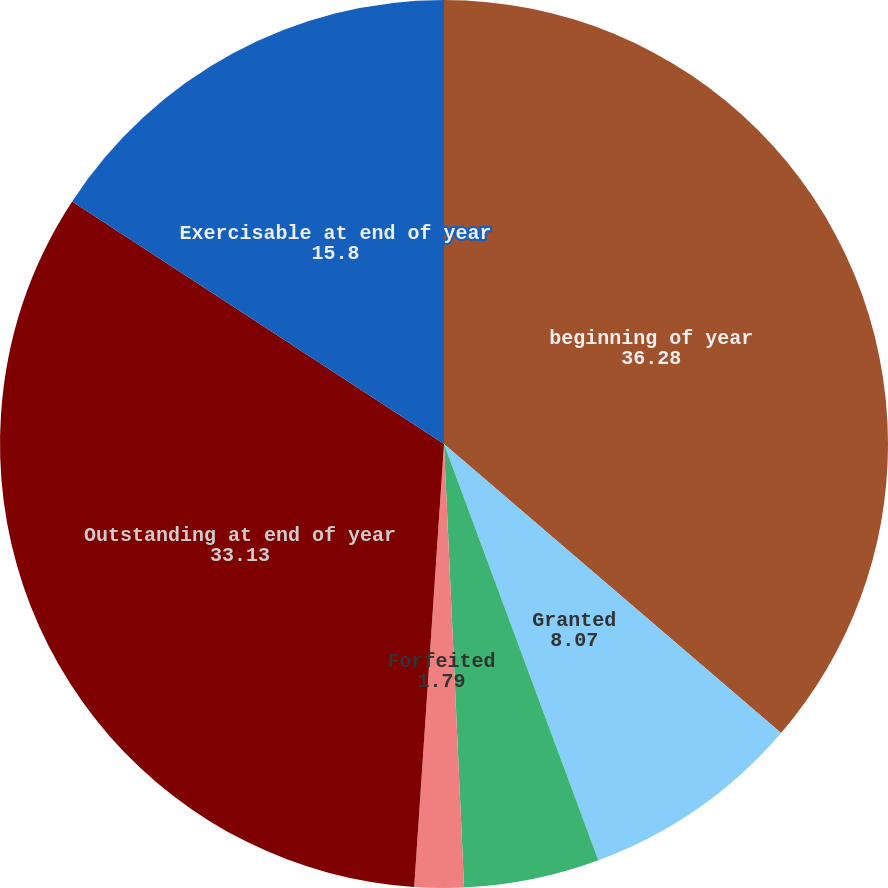<chart> <loc_0><loc_0><loc_500><loc_500><pie_chart><fcel>beginning of year<fcel>Granted<fcel>Exercised<fcel>Forfeited<fcel>Outstanding at end of year<fcel>Exercisable at end of year<nl><fcel>36.28%<fcel>8.07%<fcel>4.93%<fcel>1.79%<fcel>33.13%<fcel>15.8%<nl></chart> 